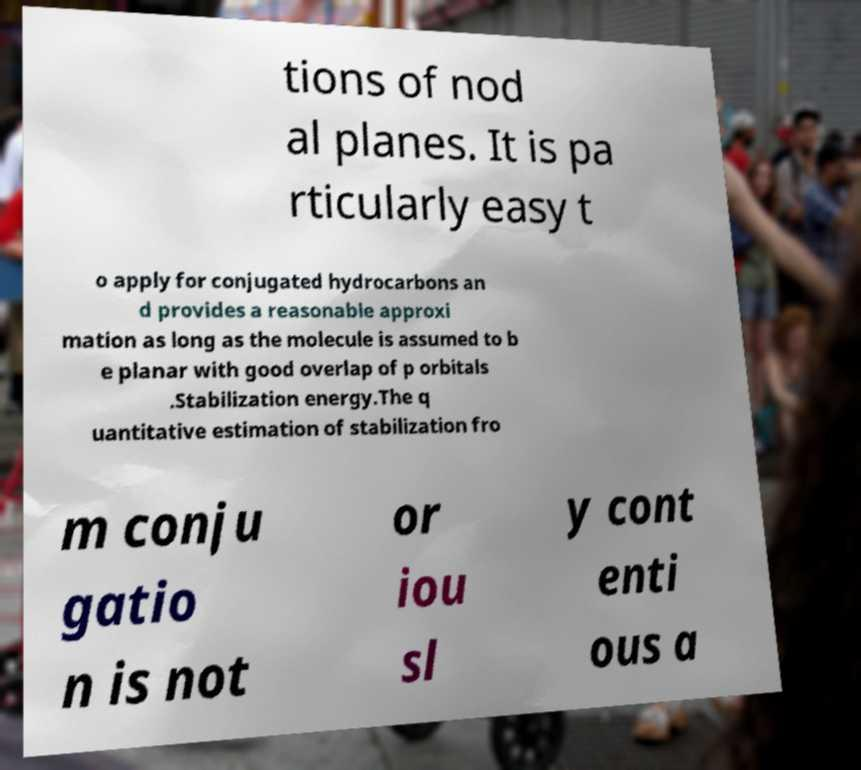Please identify and transcribe the text found in this image. tions of nod al planes. It is pa rticularly easy t o apply for conjugated hydrocarbons an d provides a reasonable approxi mation as long as the molecule is assumed to b e planar with good overlap of p orbitals .Stabilization energy.The q uantitative estimation of stabilization fro m conju gatio n is not or iou sl y cont enti ous a 